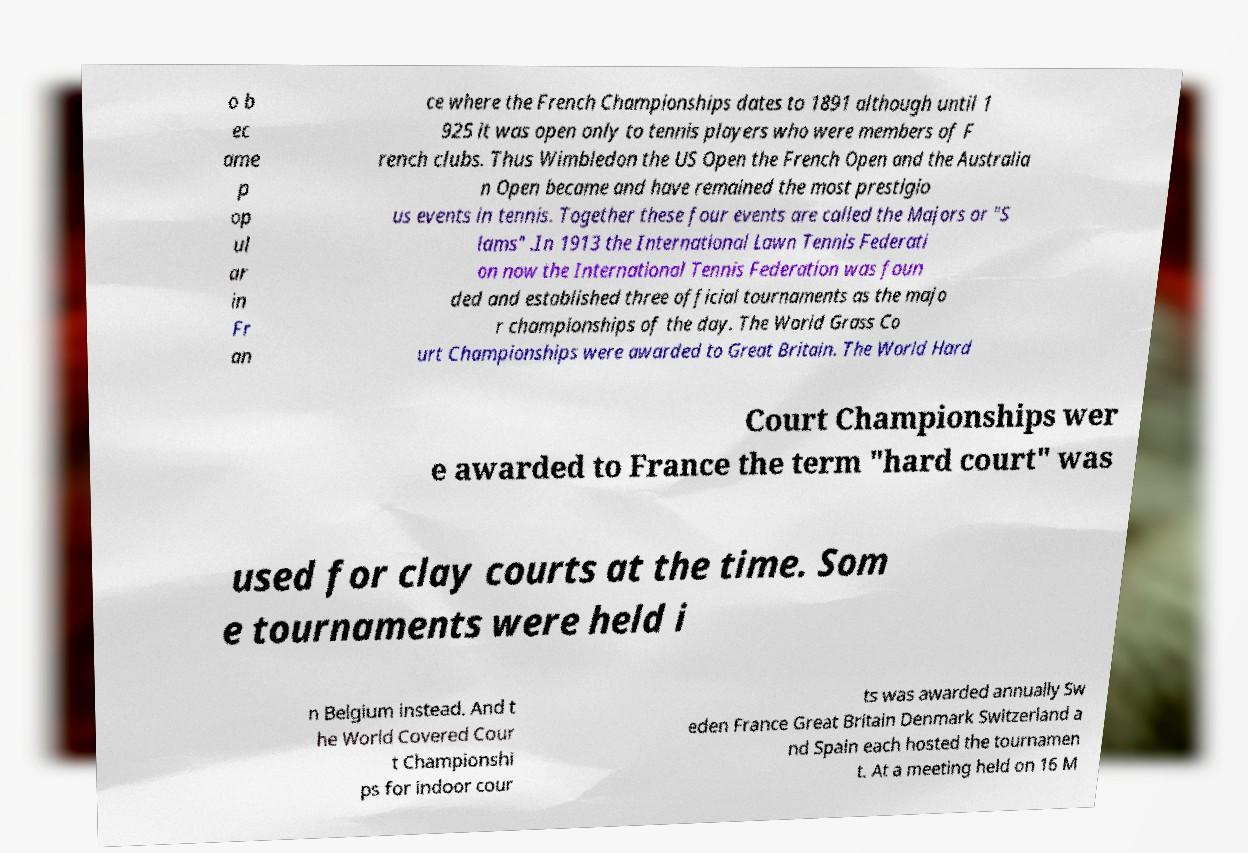There's text embedded in this image that I need extracted. Can you transcribe it verbatim? o b ec ame p op ul ar in Fr an ce where the French Championships dates to 1891 although until 1 925 it was open only to tennis players who were members of F rench clubs. Thus Wimbledon the US Open the French Open and the Australia n Open became and have remained the most prestigio us events in tennis. Together these four events are called the Majors or "S lams" .In 1913 the International Lawn Tennis Federati on now the International Tennis Federation was foun ded and established three official tournaments as the majo r championships of the day. The World Grass Co urt Championships were awarded to Great Britain. The World Hard Court Championships wer e awarded to France the term "hard court" was used for clay courts at the time. Som e tournaments were held i n Belgium instead. And t he World Covered Cour t Championshi ps for indoor cour ts was awarded annually Sw eden France Great Britain Denmark Switzerland a nd Spain each hosted the tournamen t. At a meeting held on 16 M 